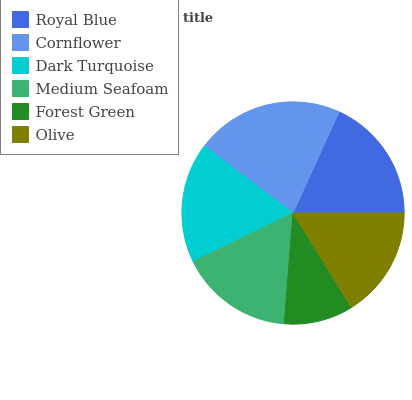Is Forest Green the minimum?
Answer yes or no. Yes. Is Cornflower the maximum?
Answer yes or no. Yes. Is Dark Turquoise the minimum?
Answer yes or no. No. Is Dark Turquoise the maximum?
Answer yes or no. No. Is Cornflower greater than Dark Turquoise?
Answer yes or no. Yes. Is Dark Turquoise less than Cornflower?
Answer yes or no. Yes. Is Dark Turquoise greater than Cornflower?
Answer yes or no. No. Is Cornflower less than Dark Turquoise?
Answer yes or no. No. Is Dark Turquoise the high median?
Answer yes or no. Yes. Is Medium Seafoam the low median?
Answer yes or no. Yes. Is Cornflower the high median?
Answer yes or no. No. Is Olive the low median?
Answer yes or no. No. 